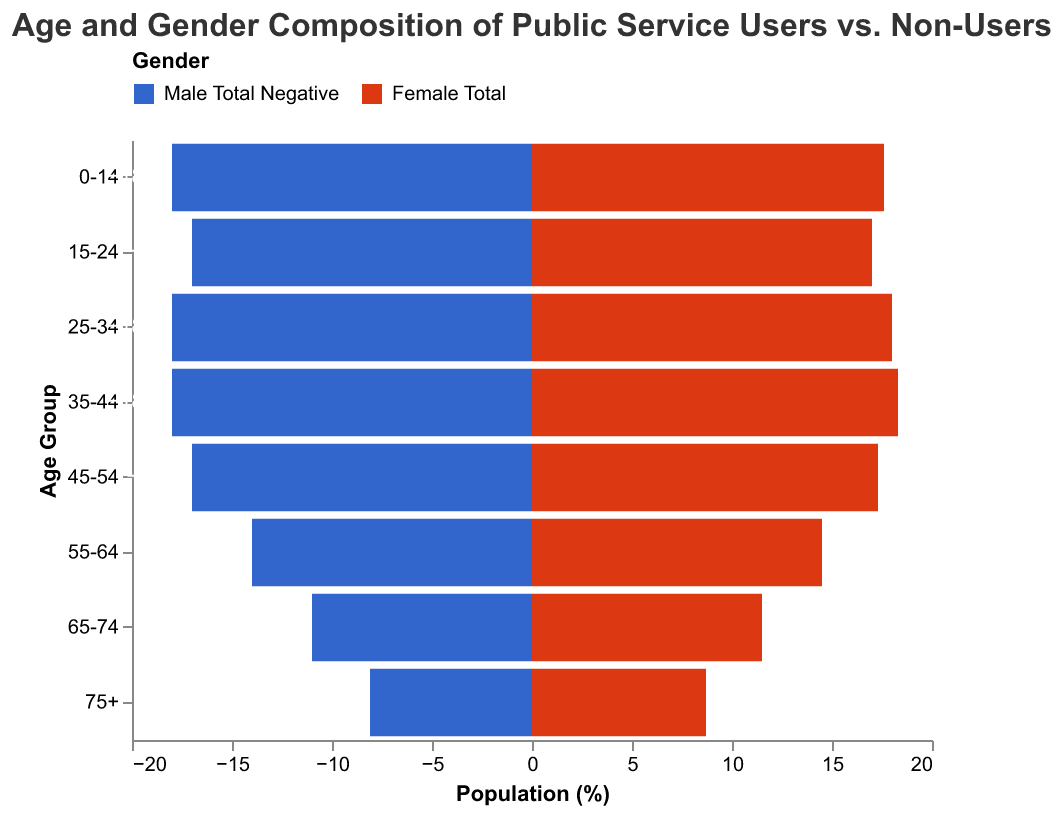What's the title of the figure? The title of the figure is found at the top of the chart and provides context for what the data represents.
Answer: Age and Gender Composition of Public Service Users vs. Non-Users What color represents the Female Total population? The colors differentiating the gender populations are shown in the legend.
Answer: Red Which age group has the highest percentage of Male Users? Locate the bars for Male Users in each age group and find the one with the highest value.
Answer: 35-44 What is the total percentage of Female Non-Users in the 45-54 age group? Find the bar representing Female Non-Users in the 45-54 age group and note the value.
Answer: 3.8% Which age group shows a larger percentage of female users compared to male users? Compare the heights of the bars for Female Users and Male Users within each age group to find where the female bar is taller.
Answer: 15-24 How does the percentage of Male Users in the 25-34 age group compare to the Male Non-Users in the same age group? Compare the value of Male Users to Male Non-Users within the 25-34 age group.
Answer: Higher What is the combined percentage of Male and Female Non-Users in the 0-14 age group? Sum the percentages of Male Non-Users and Female Non-Users in the 0-14 age group.
Answer: 25.3% Which age group has the smallest percentage of Female Users? Compare the bars representing Female Users across all age groups to find the smallest value.
Answer: 0-14 In the 75+ age group, is there a higher percentage of Male or Female Users? Compare the bars representing Male Users and Female Users in the 75+ age group.
Answer: Female Users What is the difference in percentage between Female Users and Female Non-Users in the 55-64 age group? Subtract the percentage of Female Non-Users from Female Users in the 55-64 age group.
Answer: 9.1% 